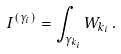<formula> <loc_0><loc_0><loc_500><loc_500>I ^ { ( \gamma _ { i } ) } = \int _ { { \gamma } _ { k _ { i } } } W _ { k _ { i } } \, .</formula> 